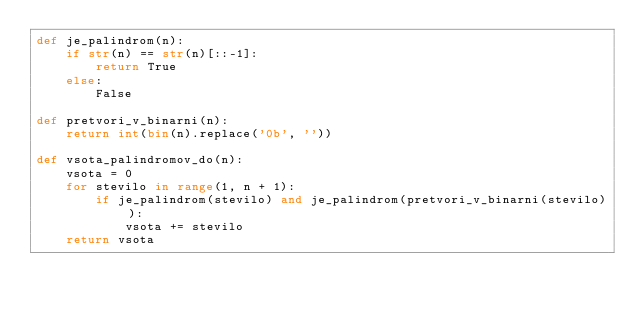Convert code to text. <code><loc_0><loc_0><loc_500><loc_500><_Python_>def je_palindrom(n):
    if str(n) == str(n)[::-1]:
        return True
    else:
        False

def pretvori_v_binarni(n):
    return int(bin(n).replace('0b', ''))

def vsota_palindromov_do(n):
    vsota = 0
    for stevilo in range(1, n + 1):
        if je_palindrom(stevilo) and je_palindrom(pretvori_v_binarni(stevilo)):
            vsota += stevilo
    return vsota
</code> 